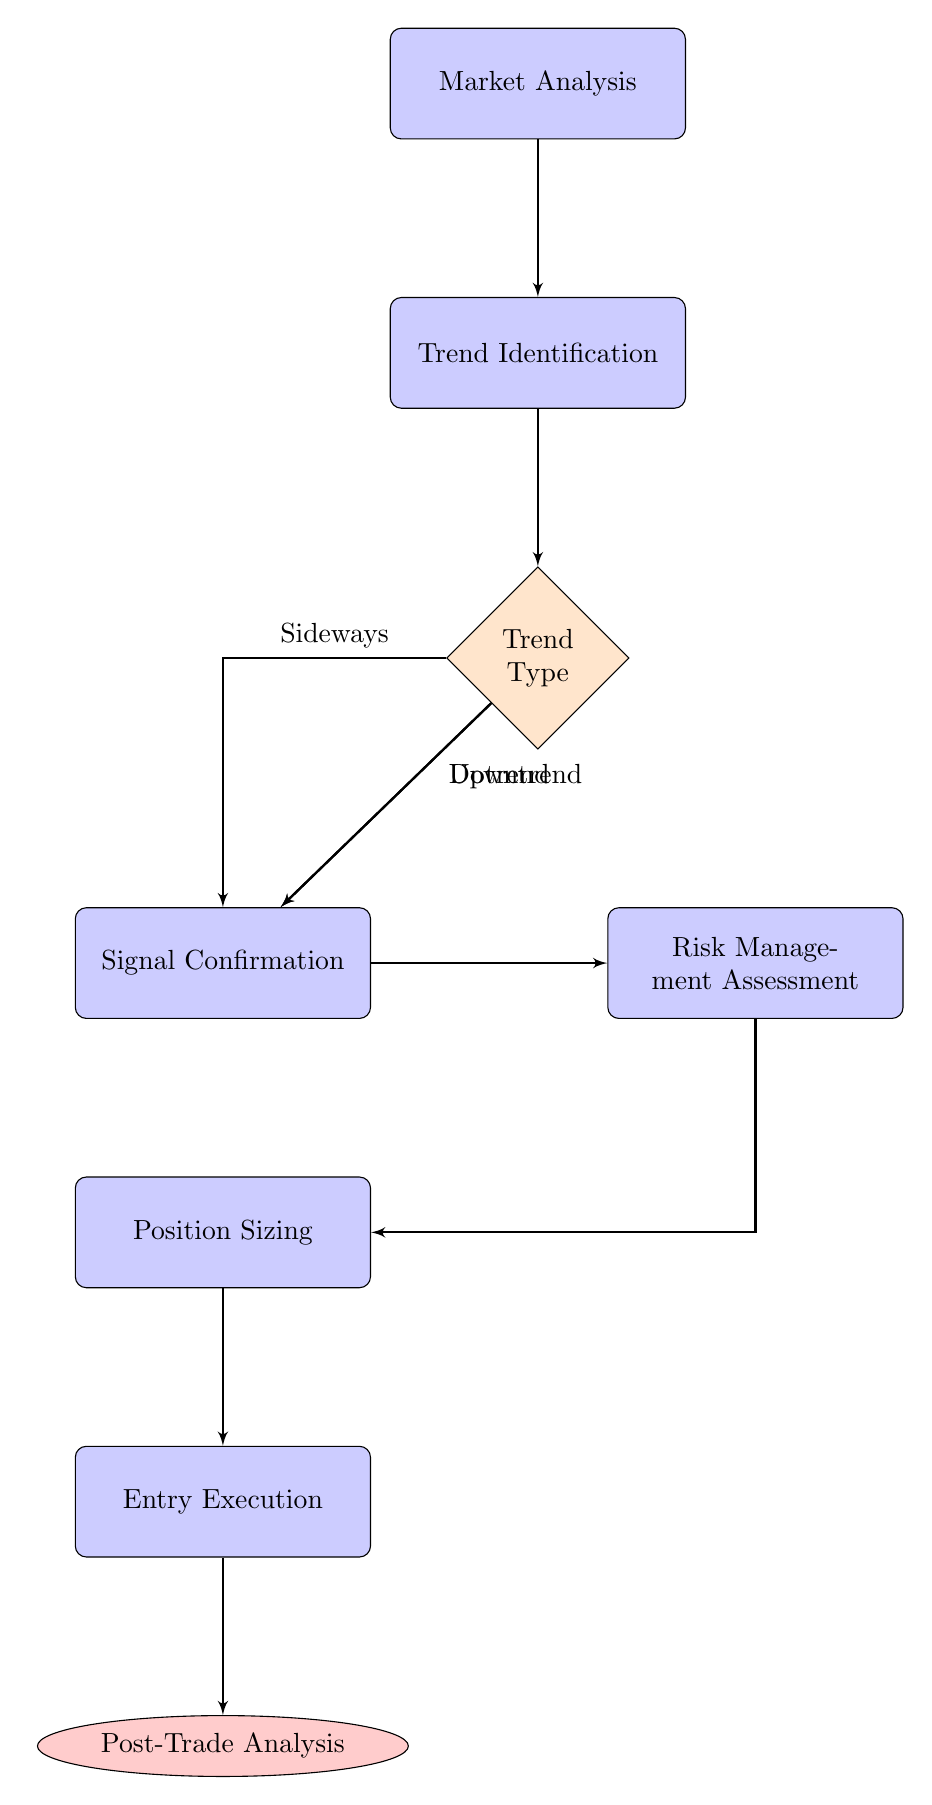What is the first node in the diagram? The first node in the diagram is "Market Analysis," which is the starting point for the decision-making process for entering a trade.
Answer: Market Analysis How many nodes are in the diagram? The diagram consists of a total of 7 nodes, which include Market Analysis, Trend Identification, Signal Confirmation, Risk Management Assessment, Position Sizing, Entry Execution, and Post-Trade Analysis.
Answer: 7 What node follows "Signal Confirmation"? After "Signal Confirmation," the next node in the sequence is "Risk Management Assessment," which evaluates risk before moving forward.
Answer: Risk Management Assessment What condition leads from "Trend Identification" to "Signal Confirmation"? The conditions from "Trend Identification" that lead to "Signal Confirmation" include Uptrend, Downtrend, and Sideways. Each of these conditions confirms entry signals aligning with the identified trend.
Answer: Uptrend, Downtrend, Sideways What is the final node in the diagram? The final node in the diagram is "Post-Trade Analysis," which focuses on reviewing trade outcomes to improve future strategies.
Answer: Post-Trade Analysis Which block comes after "Position Sizing"? The block that comes immediately after "Position Sizing" in the decision-making process is "Entry Execution," where the actual trade is executed.
Answer: Entry Execution Is there a decision diamond in the diagram? Yes, there is a decision diamond in the diagram labeled "Trend Type," which relates to determining the type of trend before proceeding with signal confirmation.
Answer: Yes What flows directly from "Risk Management Assessment"? After "Risk Management Assessment," the process flows directly into "Position Sizing," which involves deciding the size of the trade.
Answer: Position Sizing What type of analysis is performed last in the process? The last type of analysis performed in the process is "Post-Trade Analysis," which is a review of the trade outcomes.
Answer: Post-Trade Analysis 